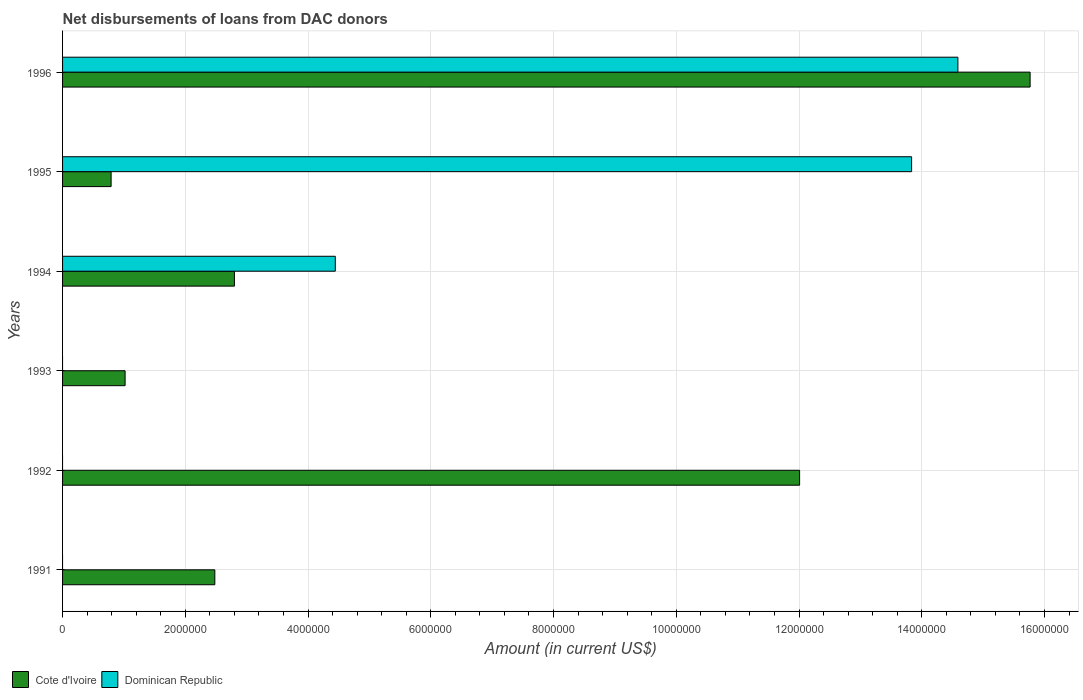Are the number of bars on each tick of the Y-axis equal?
Make the answer very short. No. In how many cases, is the number of bars for a given year not equal to the number of legend labels?
Give a very brief answer. 3. What is the amount of loans disbursed in Dominican Republic in 1994?
Ensure brevity in your answer.  4.44e+06. Across all years, what is the maximum amount of loans disbursed in Cote d'Ivoire?
Provide a succinct answer. 1.58e+07. What is the total amount of loans disbursed in Cote d'Ivoire in the graph?
Keep it short and to the point. 3.49e+07. What is the difference between the amount of loans disbursed in Cote d'Ivoire in 1991 and that in 1994?
Offer a very short reply. -3.19e+05. What is the difference between the amount of loans disbursed in Cote d'Ivoire in 1993 and the amount of loans disbursed in Dominican Republic in 1996?
Keep it short and to the point. -1.36e+07. What is the average amount of loans disbursed in Cote d'Ivoire per year?
Offer a very short reply. 5.81e+06. In the year 1995, what is the difference between the amount of loans disbursed in Cote d'Ivoire and amount of loans disbursed in Dominican Republic?
Give a very brief answer. -1.30e+07. What is the ratio of the amount of loans disbursed in Cote d'Ivoire in 1991 to that in 1995?
Provide a short and direct response. 3.14. Is the difference between the amount of loans disbursed in Cote d'Ivoire in 1994 and 1996 greater than the difference between the amount of loans disbursed in Dominican Republic in 1994 and 1996?
Provide a short and direct response. No. What is the difference between the highest and the second highest amount of loans disbursed in Dominican Republic?
Offer a very short reply. 7.54e+05. What is the difference between the highest and the lowest amount of loans disbursed in Cote d'Ivoire?
Your answer should be compact. 1.50e+07. How many years are there in the graph?
Provide a succinct answer. 6. Are the values on the major ticks of X-axis written in scientific E-notation?
Offer a very short reply. No. Where does the legend appear in the graph?
Keep it short and to the point. Bottom left. How many legend labels are there?
Provide a succinct answer. 2. What is the title of the graph?
Make the answer very short. Net disbursements of loans from DAC donors. Does "Greece" appear as one of the legend labels in the graph?
Your answer should be compact. No. What is the Amount (in current US$) of Cote d'Ivoire in 1991?
Offer a terse response. 2.48e+06. What is the Amount (in current US$) of Dominican Republic in 1991?
Ensure brevity in your answer.  0. What is the Amount (in current US$) in Cote d'Ivoire in 1992?
Provide a succinct answer. 1.20e+07. What is the Amount (in current US$) of Cote d'Ivoire in 1993?
Your response must be concise. 1.02e+06. What is the Amount (in current US$) of Dominican Republic in 1993?
Ensure brevity in your answer.  0. What is the Amount (in current US$) in Cote d'Ivoire in 1994?
Provide a short and direct response. 2.80e+06. What is the Amount (in current US$) in Dominican Republic in 1994?
Offer a terse response. 4.44e+06. What is the Amount (in current US$) in Cote d'Ivoire in 1995?
Your answer should be very brief. 7.91e+05. What is the Amount (in current US$) of Dominican Republic in 1995?
Provide a succinct answer. 1.38e+07. What is the Amount (in current US$) in Cote d'Ivoire in 1996?
Provide a succinct answer. 1.58e+07. What is the Amount (in current US$) of Dominican Republic in 1996?
Provide a succinct answer. 1.46e+07. Across all years, what is the maximum Amount (in current US$) of Cote d'Ivoire?
Your response must be concise. 1.58e+07. Across all years, what is the maximum Amount (in current US$) in Dominican Republic?
Keep it short and to the point. 1.46e+07. Across all years, what is the minimum Amount (in current US$) of Cote d'Ivoire?
Provide a short and direct response. 7.91e+05. Across all years, what is the minimum Amount (in current US$) of Dominican Republic?
Give a very brief answer. 0. What is the total Amount (in current US$) of Cote d'Ivoire in the graph?
Provide a succinct answer. 3.49e+07. What is the total Amount (in current US$) in Dominican Republic in the graph?
Give a very brief answer. 3.29e+07. What is the difference between the Amount (in current US$) of Cote d'Ivoire in 1991 and that in 1992?
Your answer should be compact. -9.53e+06. What is the difference between the Amount (in current US$) of Cote d'Ivoire in 1991 and that in 1993?
Give a very brief answer. 1.46e+06. What is the difference between the Amount (in current US$) of Cote d'Ivoire in 1991 and that in 1994?
Keep it short and to the point. -3.19e+05. What is the difference between the Amount (in current US$) of Cote d'Ivoire in 1991 and that in 1995?
Offer a terse response. 1.69e+06. What is the difference between the Amount (in current US$) in Cote d'Ivoire in 1991 and that in 1996?
Offer a terse response. -1.33e+07. What is the difference between the Amount (in current US$) of Cote d'Ivoire in 1992 and that in 1993?
Offer a very short reply. 1.10e+07. What is the difference between the Amount (in current US$) of Cote d'Ivoire in 1992 and that in 1994?
Keep it short and to the point. 9.21e+06. What is the difference between the Amount (in current US$) of Cote d'Ivoire in 1992 and that in 1995?
Ensure brevity in your answer.  1.12e+07. What is the difference between the Amount (in current US$) in Cote d'Ivoire in 1992 and that in 1996?
Provide a short and direct response. -3.76e+06. What is the difference between the Amount (in current US$) of Cote d'Ivoire in 1993 and that in 1994?
Make the answer very short. -1.78e+06. What is the difference between the Amount (in current US$) of Cote d'Ivoire in 1993 and that in 1995?
Ensure brevity in your answer.  2.28e+05. What is the difference between the Amount (in current US$) of Cote d'Ivoire in 1993 and that in 1996?
Ensure brevity in your answer.  -1.47e+07. What is the difference between the Amount (in current US$) of Cote d'Ivoire in 1994 and that in 1995?
Ensure brevity in your answer.  2.01e+06. What is the difference between the Amount (in current US$) of Dominican Republic in 1994 and that in 1995?
Your answer should be very brief. -9.39e+06. What is the difference between the Amount (in current US$) of Cote d'Ivoire in 1994 and that in 1996?
Your response must be concise. -1.30e+07. What is the difference between the Amount (in current US$) of Dominican Republic in 1994 and that in 1996?
Your response must be concise. -1.01e+07. What is the difference between the Amount (in current US$) of Cote d'Ivoire in 1995 and that in 1996?
Your answer should be compact. -1.50e+07. What is the difference between the Amount (in current US$) in Dominican Republic in 1995 and that in 1996?
Ensure brevity in your answer.  -7.54e+05. What is the difference between the Amount (in current US$) in Cote d'Ivoire in 1991 and the Amount (in current US$) in Dominican Republic in 1994?
Your answer should be very brief. -1.96e+06. What is the difference between the Amount (in current US$) in Cote d'Ivoire in 1991 and the Amount (in current US$) in Dominican Republic in 1995?
Your answer should be compact. -1.14e+07. What is the difference between the Amount (in current US$) of Cote d'Ivoire in 1991 and the Amount (in current US$) of Dominican Republic in 1996?
Offer a terse response. -1.21e+07. What is the difference between the Amount (in current US$) of Cote d'Ivoire in 1992 and the Amount (in current US$) of Dominican Republic in 1994?
Your response must be concise. 7.57e+06. What is the difference between the Amount (in current US$) of Cote d'Ivoire in 1992 and the Amount (in current US$) of Dominican Republic in 1995?
Provide a succinct answer. -1.82e+06. What is the difference between the Amount (in current US$) of Cote d'Ivoire in 1992 and the Amount (in current US$) of Dominican Republic in 1996?
Keep it short and to the point. -2.58e+06. What is the difference between the Amount (in current US$) of Cote d'Ivoire in 1993 and the Amount (in current US$) of Dominican Republic in 1994?
Give a very brief answer. -3.42e+06. What is the difference between the Amount (in current US$) in Cote d'Ivoire in 1993 and the Amount (in current US$) in Dominican Republic in 1995?
Offer a very short reply. -1.28e+07. What is the difference between the Amount (in current US$) of Cote d'Ivoire in 1993 and the Amount (in current US$) of Dominican Republic in 1996?
Keep it short and to the point. -1.36e+07. What is the difference between the Amount (in current US$) of Cote d'Ivoire in 1994 and the Amount (in current US$) of Dominican Republic in 1995?
Provide a short and direct response. -1.10e+07. What is the difference between the Amount (in current US$) of Cote d'Ivoire in 1994 and the Amount (in current US$) of Dominican Republic in 1996?
Offer a very short reply. -1.18e+07. What is the difference between the Amount (in current US$) of Cote d'Ivoire in 1995 and the Amount (in current US$) of Dominican Republic in 1996?
Offer a very short reply. -1.38e+07. What is the average Amount (in current US$) in Cote d'Ivoire per year?
Offer a terse response. 5.81e+06. What is the average Amount (in current US$) in Dominican Republic per year?
Your answer should be very brief. 5.48e+06. In the year 1994, what is the difference between the Amount (in current US$) of Cote d'Ivoire and Amount (in current US$) of Dominican Republic?
Your answer should be compact. -1.64e+06. In the year 1995, what is the difference between the Amount (in current US$) of Cote d'Ivoire and Amount (in current US$) of Dominican Republic?
Your answer should be very brief. -1.30e+07. In the year 1996, what is the difference between the Amount (in current US$) in Cote d'Ivoire and Amount (in current US$) in Dominican Republic?
Provide a short and direct response. 1.18e+06. What is the ratio of the Amount (in current US$) of Cote d'Ivoire in 1991 to that in 1992?
Your answer should be compact. 0.21. What is the ratio of the Amount (in current US$) of Cote d'Ivoire in 1991 to that in 1993?
Make the answer very short. 2.43. What is the ratio of the Amount (in current US$) in Cote d'Ivoire in 1991 to that in 1994?
Provide a short and direct response. 0.89. What is the ratio of the Amount (in current US$) in Cote d'Ivoire in 1991 to that in 1995?
Your answer should be very brief. 3.14. What is the ratio of the Amount (in current US$) of Cote d'Ivoire in 1991 to that in 1996?
Keep it short and to the point. 0.16. What is the ratio of the Amount (in current US$) in Cote d'Ivoire in 1992 to that in 1993?
Your answer should be compact. 11.79. What is the ratio of the Amount (in current US$) of Cote d'Ivoire in 1992 to that in 1994?
Keep it short and to the point. 4.29. What is the ratio of the Amount (in current US$) of Cote d'Ivoire in 1992 to that in 1995?
Make the answer very short. 15.18. What is the ratio of the Amount (in current US$) of Cote d'Ivoire in 1992 to that in 1996?
Offer a terse response. 0.76. What is the ratio of the Amount (in current US$) of Cote d'Ivoire in 1993 to that in 1994?
Provide a short and direct response. 0.36. What is the ratio of the Amount (in current US$) in Cote d'Ivoire in 1993 to that in 1995?
Ensure brevity in your answer.  1.29. What is the ratio of the Amount (in current US$) in Cote d'Ivoire in 1993 to that in 1996?
Keep it short and to the point. 0.06. What is the ratio of the Amount (in current US$) of Cote d'Ivoire in 1994 to that in 1995?
Offer a terse response. 3.54. What is the ratio of the Amount (in current US$) in Dominican Republic in 1994 to that in 1995?
Ensure brevity in your answer.  0.32. What is the ratio of the Amount (in current US$) in Cote d'Ivoire in 1994 to that in 1996?
Your answer should be very brief. 0.18. What is the ratio of the Amount (in current US$) in Dominican Republic in 1994 to that in 1996?
Provide a succinct answer. 0.3. What is the ratio of the Amount (in current US$) of Cote d'Ivoire in 1995 to that in 1996?
Keep it short and to the point. 0.05. What is the ratio of the Amount (in current US$) of Dominican Republic in 1995 to that in 1996?
Ensure brevity in your answer.  0.95. What is the difference between the highest and the second highest Amount (in current US$) in Cote d'Ivoire?
Your answer should be very brief. 3.76e+06. What is the difference between the highest and the second highest Amount (in current US$) in Dominican Republic?
Your response must be concise. 7.54e+05. What is the difference between the highest and the lowest Amount (in current US$) of Cote d'Ivoire?
Offer a very short reply. 1.50e+07. What is the difference between the highest and the lowest Amount (in current US$) in Dominican Republic?
Your response must be concise. 1.46e+07. 